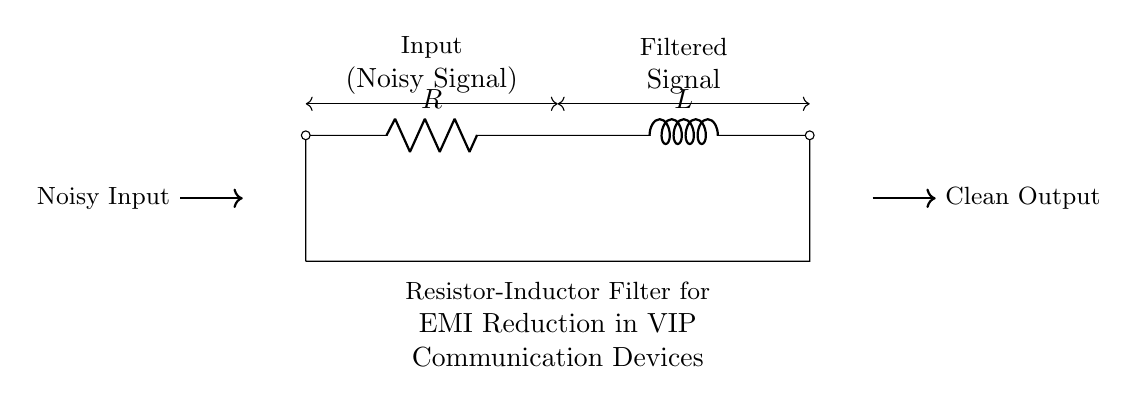What components are present in this circuit? The circuit diagram includes a resistor (R) and an inductor (L), which are essential components for creating a filter. They are connected in series to filter out unwanted frequencies from an input signal.
Answer: Resistor and inductor What is the primary function of this filter? The primary function of this resistor-inductor filter is to reduce electromagnetic interference (EMI) in the communication devices. It does this by attenuating the high-frequency noise while allowing lower-frequency signals to pass.
Answer: EMI reduction How are the components connected in this circuit? The two components are connected in series, meaning that the output of the resistor directly feeds into the inductor. This series configuration is effective for creating a low-pass filter, which is crucial for noise reduction.
Answer: Series connection What type of filter is created by this resistor-inductor combination? This combination creates a low-pass filter, which allows signals with a frequency lower than a certain cutoff frequency to pass through while attenuating frequencies higher than that cutoff. This is essential for clean communication.
Answer: Low-pass filter What is the expected output of this circuit? The expected output of the circuit is a clean output signal, free from the noisy input signal. The filtering action of the resistor and inductor removes unwanted electromagnetic interference, resulting in a more reliable communication line.
Answer: Clean output 